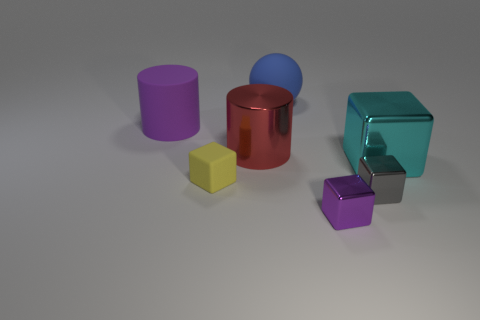Do the block that is in front of the tiny gray thing and the small object on the left side of the large red cylinder have the same material?
Provide a short and direct response. No. How many other objects are there of the same size as the yellow object?
Give a very brief answer. 2. How many things are either small cyan matte cubes or metallic things that are left of the purple metal block?
Ensure brevity in your answer.  1. Are there the same number of yellow matte objects on the right side of the tiny yellow rubber object and large red cylinders?
Your response must be concise. No. There is a large thing that is the same material as the large cube; what is its shape?
Keep it short and to the point. Cylinder. Is there a shiny object that has the same color as the big rubber ball?
Make the answer very short. No. What number of metallic objects are either purple objects or cyan blocks?
Make the answer very short. 2. What number of large blue spheres are behind the purple cylinder that is left of the red shiny thing?
Provide a short and direct response. 1. Are there the same number of red things and tiny shiny things?
Your response must be concise. No. What number of large blue balls are made of the same material as the cyan block?
Make the answer very short. 0. 